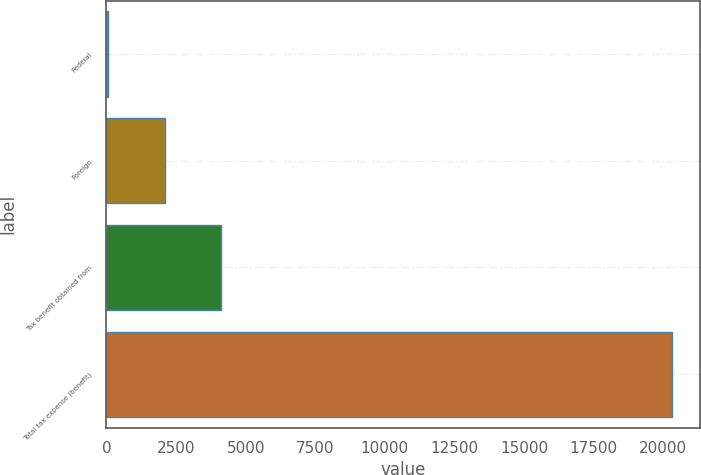<chart> <loc_0><loc_0><loc_500><loc_500><bar_chart><fcel>Federal<fcel>Foreign<fcel>Tax benefit obtained from<fcel>Total tax expense (benefit)<nl><fcel>60<fcel>2086.7<fcel>4113.4<fcel>20327<nl></chart> 